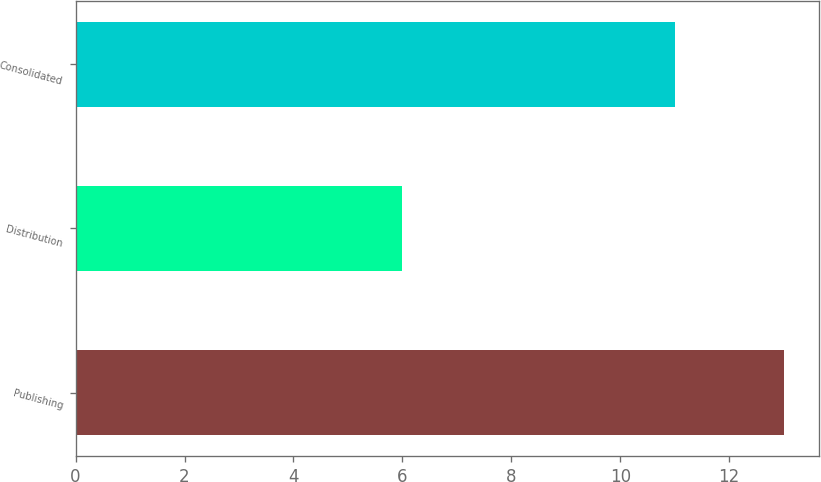<chart> <loc_0><loc_0><loc_500><loc_500><bar_chart><fcel>Publishing<fcel>Distribution<fcel>Consolidated<nl><fcel>13<fcel>6<fcel>11<nl></chart> 